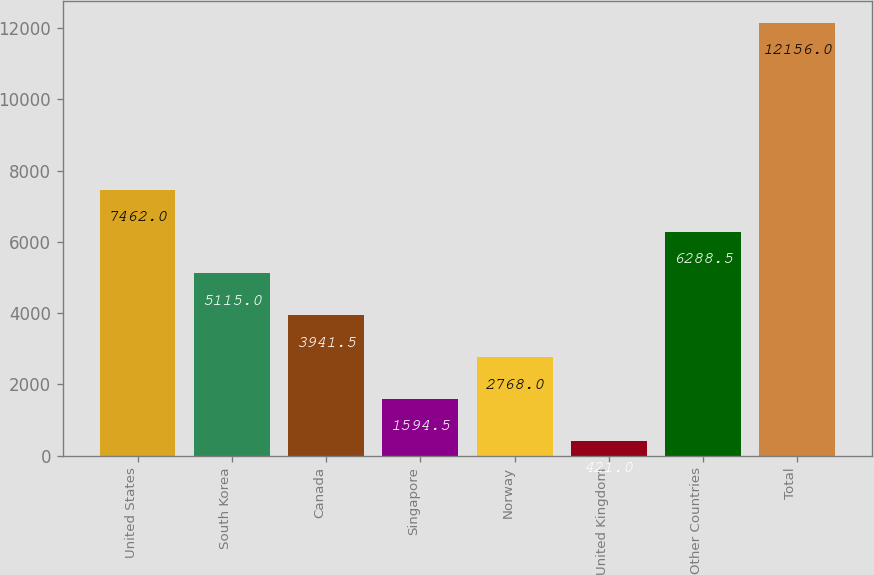Convert chart. <chart><loc_0><loc_0><loc_500><loc_500><bar_chart><fcel>United States<fcel>South Korea<fcel>Canada<fcel>Singapore<fcel>Norway<fcel>United Kingdom<fcel>Other Countries<fcel>Total<nl><fcel>7462<fcel>5115<fcel>3941.5<fcel>1594.5<fcel>2768<fcel>421<fcel>6288.5<fcel>12156<nl></chart> 